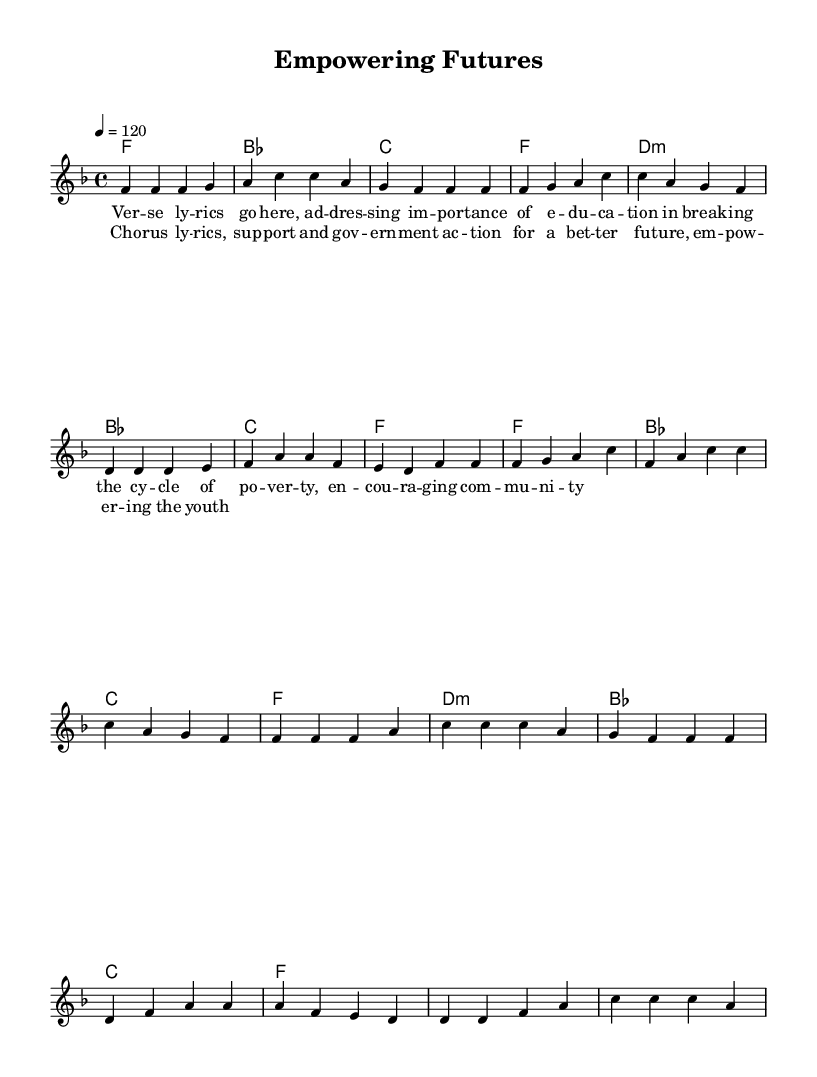What is the key signature of this music? The key signature indicated is F major, which has one flat (B flat). This can be identified at the beginning of the staff where the key signature is placed.
Answer: F major What is the time signature of the piece? The time signature is 4/4, shown at the beginning of the score next to the key signature, indicating four beats in each measure.
Answer: 4/4 What is the tempo marking for this piece? The tempo is marked as 4 = 120, indicating that there are 120 beats per minute, and the quarter note gets the beat. This information is also provided at the beginning of the music score.
Answer: 120 How many measures are in the verse section? By counting the distinct groups of notes separated by vertical lines (bar lines) in the verse section, we find there are eight measures.
Answer: eight What is the main topic addressed in the lyrics? The lyrics focus on the importance of education in breaking the cycle of poverty, which reflects a socially conscious message aimed at uplifting the community. This is inferred from the theme discussed in the verse lyrics.
Answer: education What is the chord progression used for the verse? The chord progression in the verse section is F, B flat, C, F, D minor, B flat, C, F, which can be gathered by examining the chord names written above the melody for the verses.
Answer: F, B flat, C, F, D minor What social issues does the chorus address? The chorus highlights support and government action for a better future, emphasizing empowerment for the youth, which is relevant to Afrobeat's socially conscious themes. This can be concluded from analyzing the content of the chorus lyrics.
Answer: empowerment 